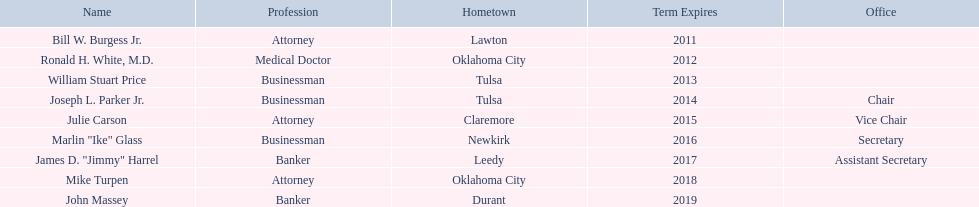Where is bill w. burgess jr. from? Lawton. Where is price and parker from? Tulsa. Who is from the same state as white? Mike Turpen. Who are the commerce individuals? Bill W. Burgess Jr., Ronald H. White, M.D., William Stuart Price, Joseph L. Parker Jr., Julie Carson, Marlin "Ike" Glass, James D. "Jimmy" Harrel, Mike Turpen, John Massey. Which were born in tulsa? William Stuart Price, Joseph L. Parker Jr. Of these, which one was different from william stuart price? Joseph L. Parker Jr. 